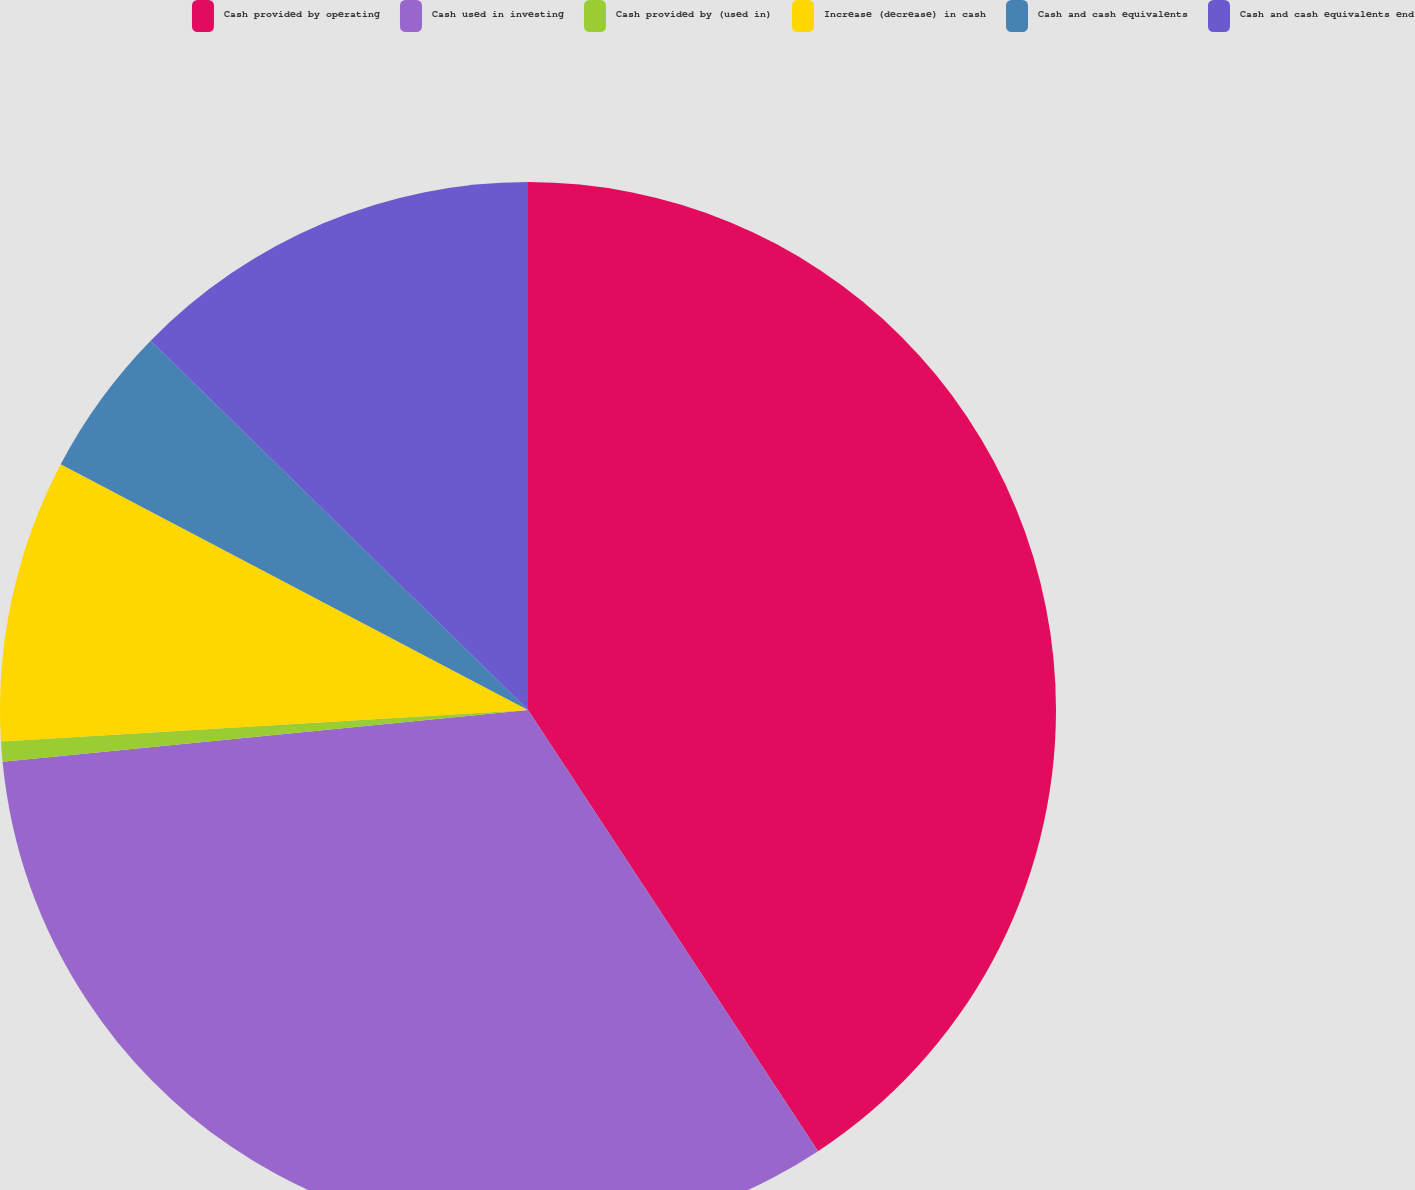Convert chart. <chart><loc_0><loc_0><loc_500><loc_500><pie_chart><fcel>Cash provided by operating<fcel>Cash used in investing<fcel>Cash provided by (used in)<fcel>Increase (decrease) in cash<fcel>Cash and cash equivalents<fcel>Cash and cash equivalents end<nl><fcel>40.74%<fcel>32.69%<fcel>0.61%<fcel>8.66%<fcel>4.62%<fcel>12.67%<nl></chart> 